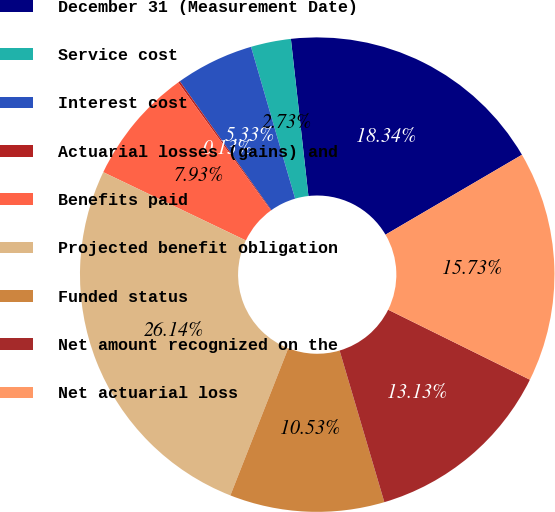Convert chart. <chart><loc_0><loc_0><loc_500><loc_500><pie_chart><fcel>December 31 (Measurement Date)<fcel>Service cost<fcel>Interest cost<fcel>Actuarial losses (gains) and<fcel>Benefits paid<fcel>Projected benefit obligation<fcel>Funded status<fcel>Net amount recognized on the<fcel>Net actuarial loss<nl><fcel>18.34%<fcel>2.73%<fcel>5.33%<fcel>0.13%<fcel>7.93%<fcel>26.14%<fcel>10.53%<fcel>13.13%<fcel>15.73%<nl></chart> 